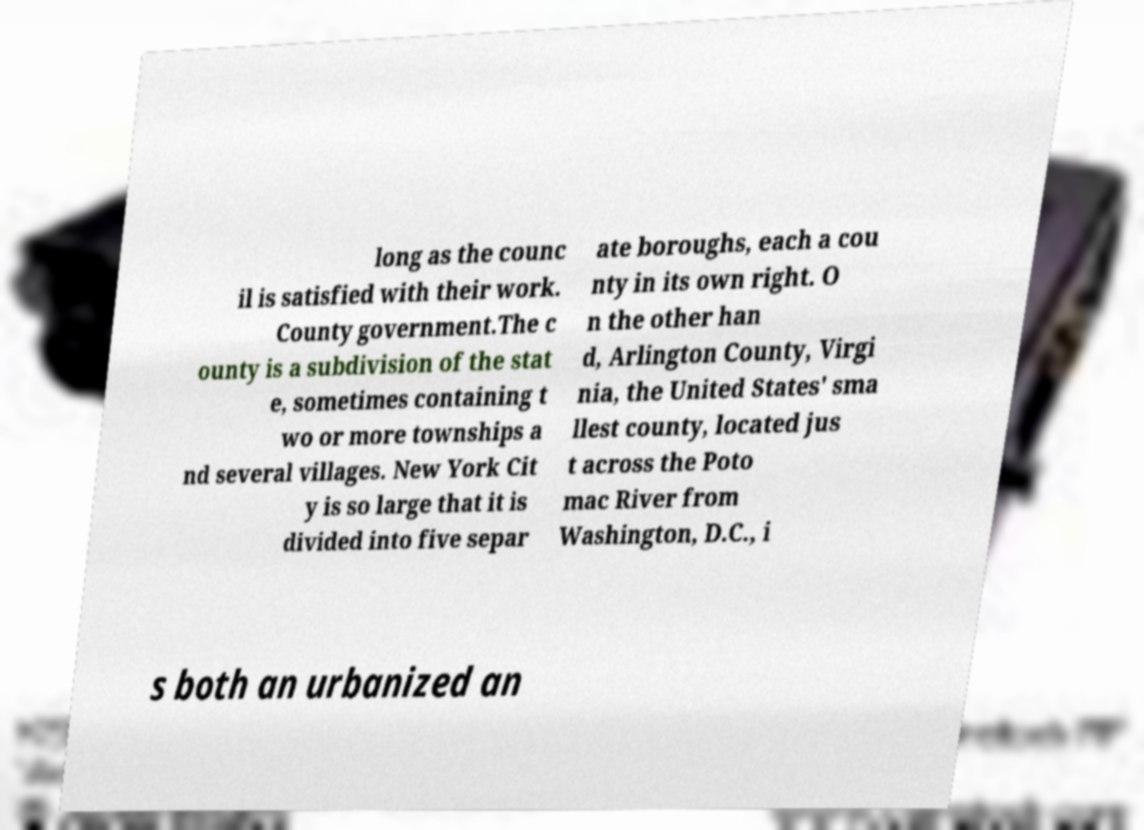Can you accurately transcribe the text from the provided image for me? long as the counc il is satisfied with their work. County government.The c ounty is a subdivision of the stat e, sometimes containing t wo or more townships a nd several villages. New York Cit y is so large that it is divided into five separ ate boroughs, each a cou nty in its own right. O n the other han d, Arlington County, Virgi nia, the United States' sma llest county, located jus t across the Poto mac River from Washington, D.C., i s both an urbanized an 